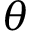Convert formula to latex. <formula><loc_0><loc_0><loc_500><loc_500>\theta</formula> 